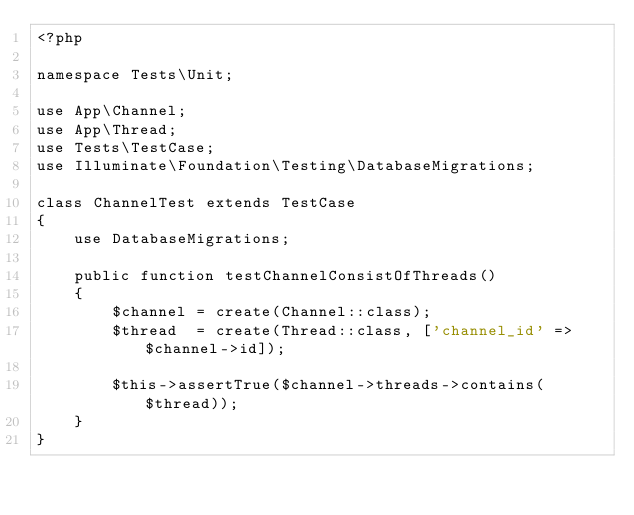<code> <loc_0><loc_0><loc_500><loc_500><_PHP_><?php

namespace Tests\Unit;

use App\Channel;
use App\Thread;
use Tests\TestCase;
use Illuminate\Foundation\Testing\DatabaseMigrations;

class ChannelTest extends TestCase
{
    use DatabaseMigrations;

    public function testChannelConsistOfThreads()
    {
        $channel = create(Channel::class);
        $thread  = create(Thread::class, ['channel_id' => $channel->id]);

        $this->assertTrue($channel->threads->contains($thread));
    }
}
</code> 